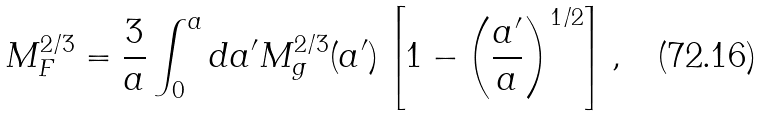<formula> <loc_0><loc_0><loc_500><loc_500>M _ { F } ^ { 2 / 3 } = \frac { 3 } { a } \int _ { 0 } ^ { a } d a ^ { \prime } M _ { g } ^ { 2 / 3 } ( a ^ { \prime } ) \left [ 1 - \left ( \frac { a ^ { \prime } } { a } \right ) ^ { 1 / 2 } \right ] ,</formula> 